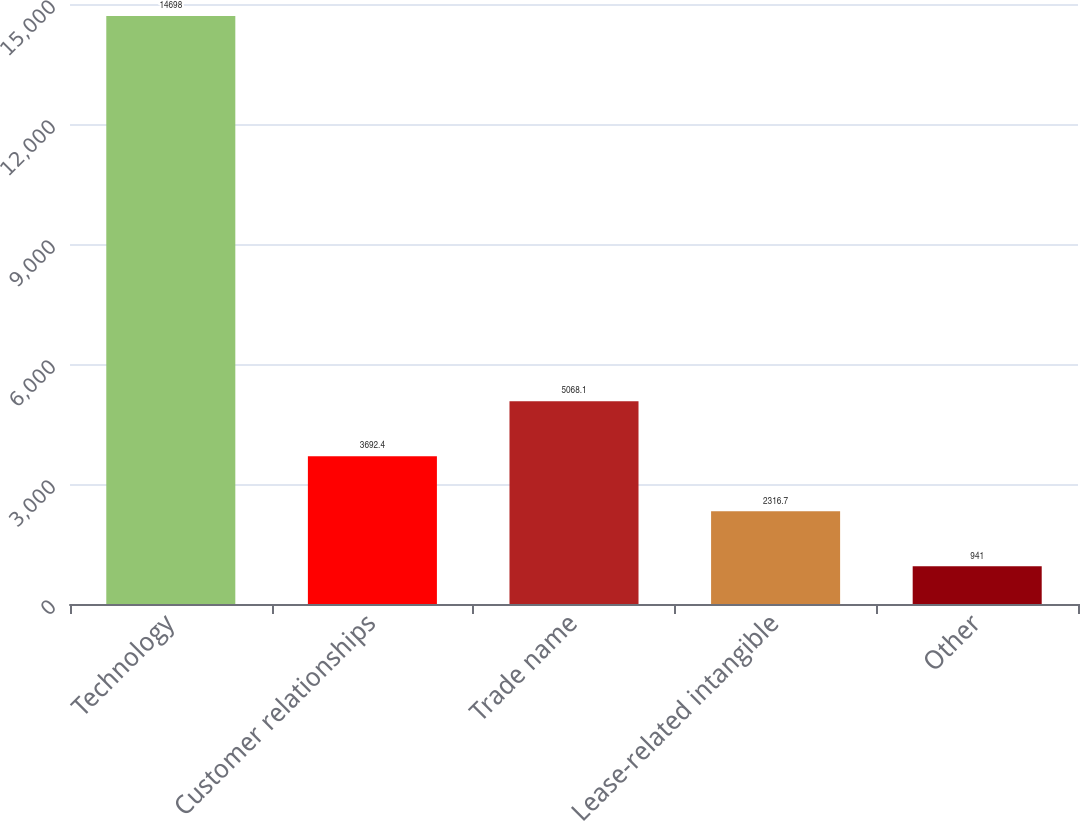Convert chart. <chart><loc_0><loc_0><loc_500><loc_500><bar_chart><fcel>Technology<fcel>Customer relationships<fcel>Trade name<fcel>Lease-related intangible<fcel>Other<nl><fcel>14698<fcel>3692.4<fcel>5068.1<fcel>2316.7<fcel>941<nl></chart> 